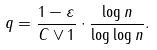<formula> <loc_0><loc_0><loc_500><loc_500>q = \frac { 1 - \varepsilon } { C \vee 1 } \cdot \frac { \log n } { \log \log n } .</formula> 